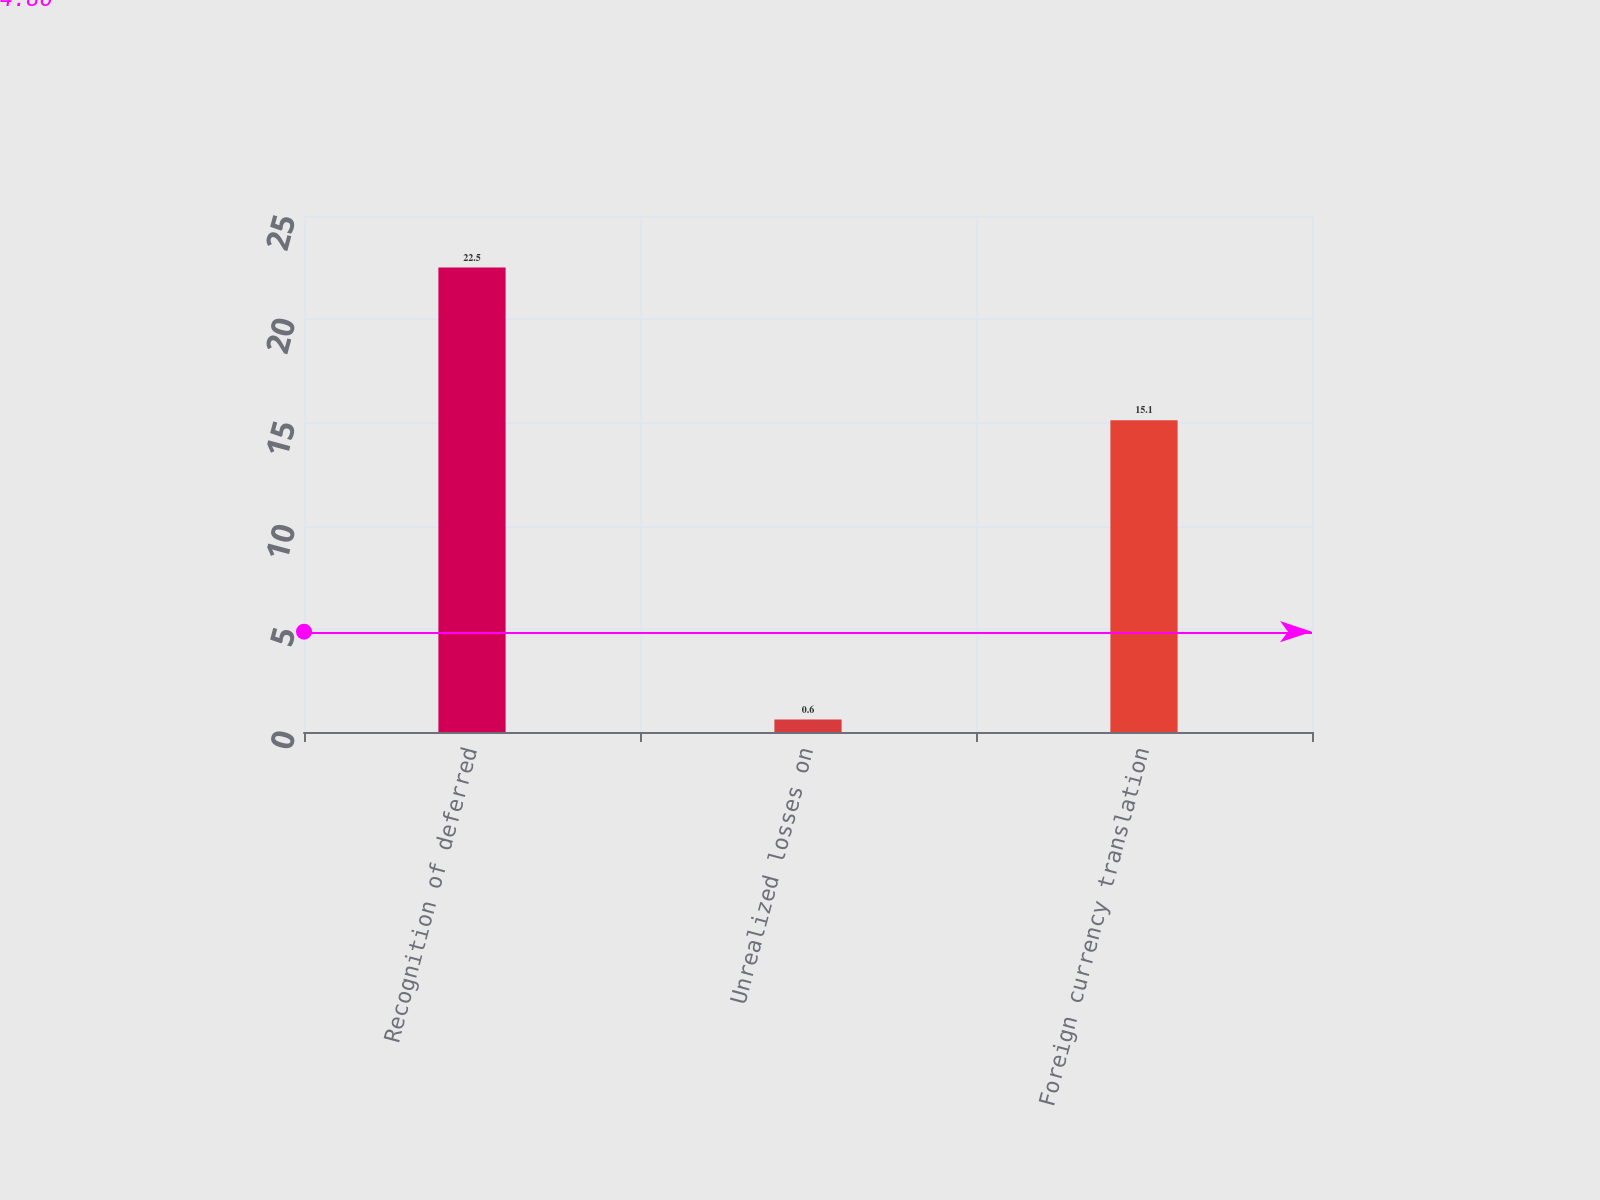<chart> <loc_0><loc_0><loc_500><loc_500><bar_chart><fcel>Recognition of deferred<fcel>Unrealized losses on<fcel>Foreign currency translation<nl><fcel>22.5<fcel>0.6<fcel>15.1<nl></chart> 